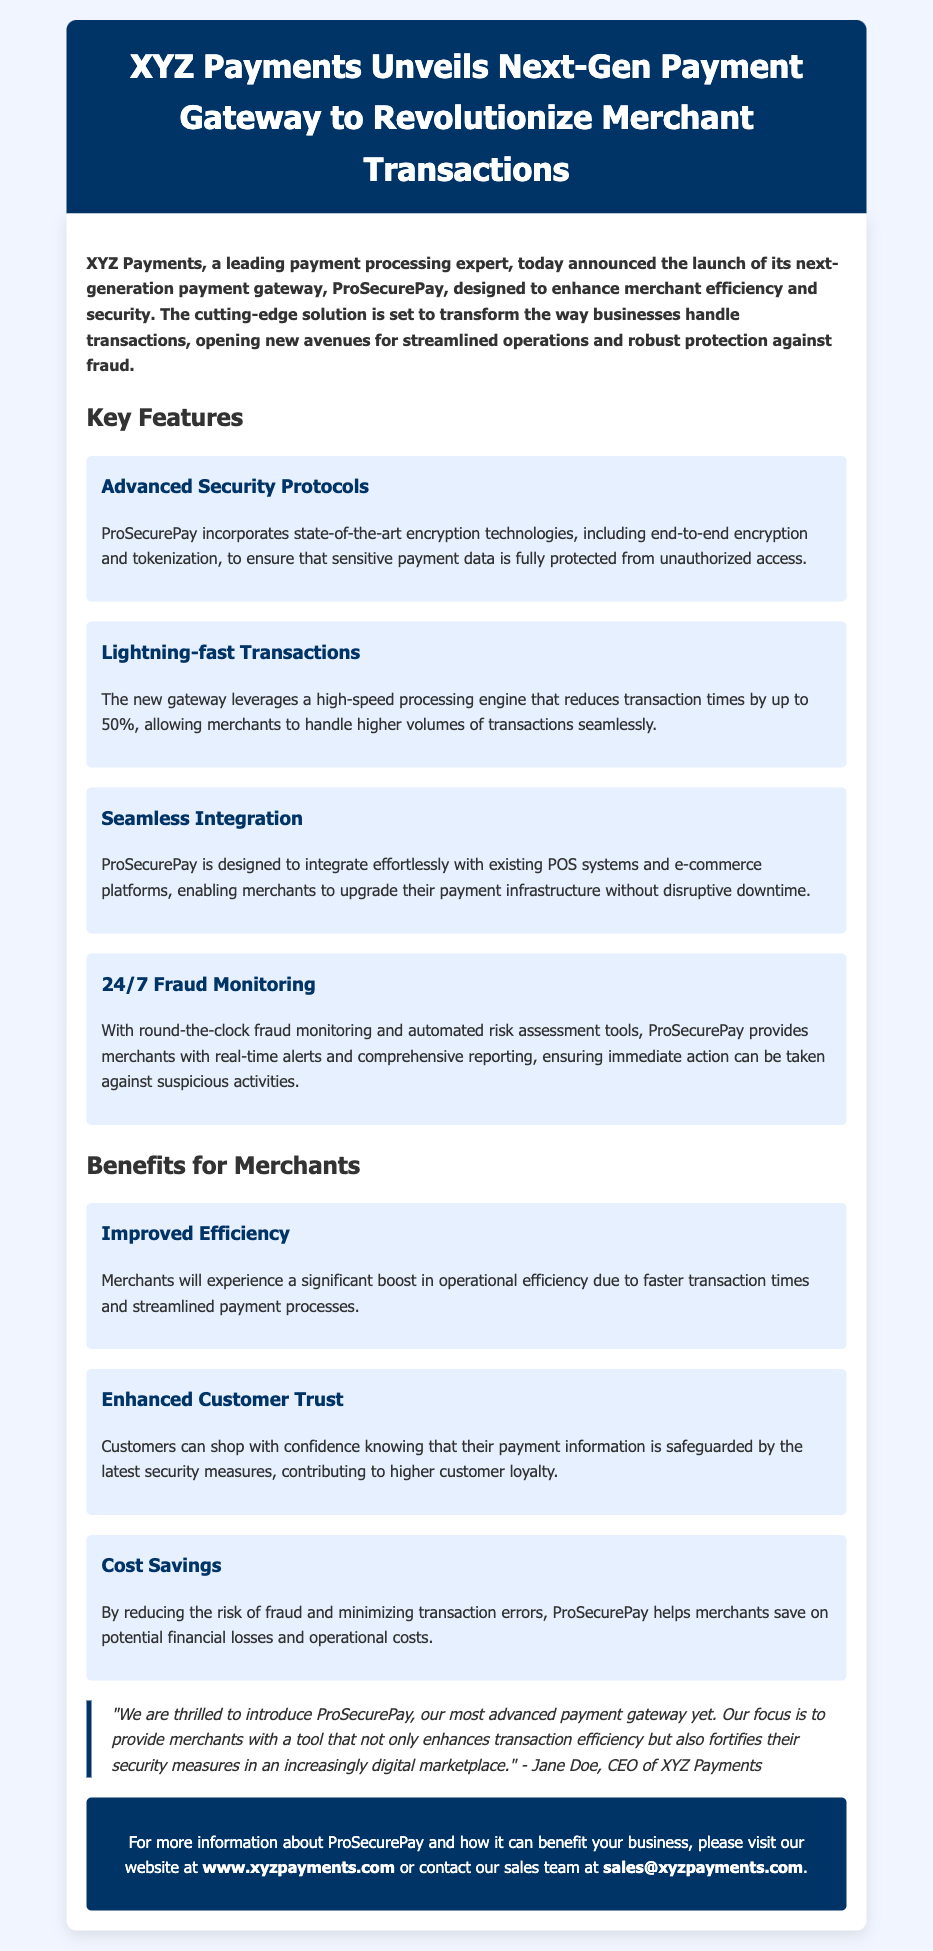What is the name of the newly launched payment gateway? The name of the newly launched payment gateway is mentioned in the header of the press release as ProSecurePay.
Answer: ProSecurePay Who is the CEO of XYZ Payments? The CEO of XYZ Payments is quoted at the end of the document providing insights about the launch, and her name is Jane Doe.
Answer: Jane Doe What percentage can transaction times be reduced by using ProSecurePay? The document states that transaction times can be reduced by up to 50% with the new gateway.
Answer: 50% What feature ensures protection from unauthorized access? The advanced security protocols include encryption technologies such as end-to-end encryption and tokenization to protect sensitive payment data.
Answer: Advanced Security Protocols What specific benefit does ProSecurePay provide in terms of cost? The document highlights that ProSecurePay helps merchants save on potential financial losses and operational costs by reducing the risk of fraud and minimizing transaction errors.
Answer: Cost Savings What is the main focus of ProSecurePay according to the CEO's quote? According to Jane Doe, the main focus of ProSecurePay is to enhance transaction efficiency and fortify security measures in the digital marketplace.
Answer: Enhance transaction efficiency and fortify security measures How does ProSecurePay assist merchants outside of transaction speed? The document mentions that ProSecurePay provides 24/7 fraud monitoring and automated risk assessment tools for merchants.
Answer: 24/7 Fraud Monitoring What company announced the launch of ProSecurePay? The press release indicates that XYZ Payments is the company that announced the launch of ProSecurePay.
Answer: XYZ Payments 